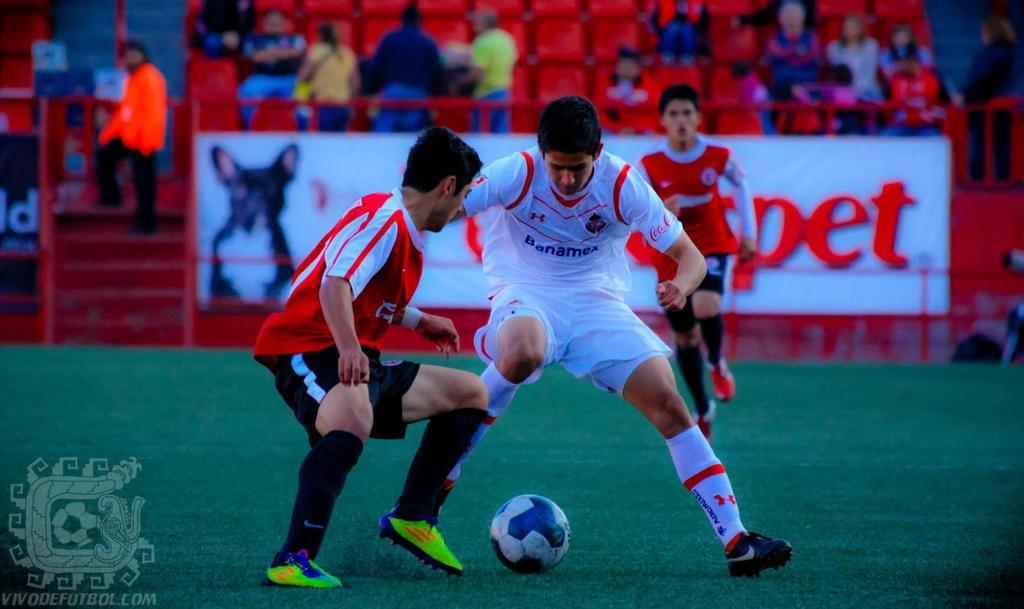<image>
Write a terse but informative summary of the picture. The soccer player in the white Banamex jersey is defending a ball from another player. 